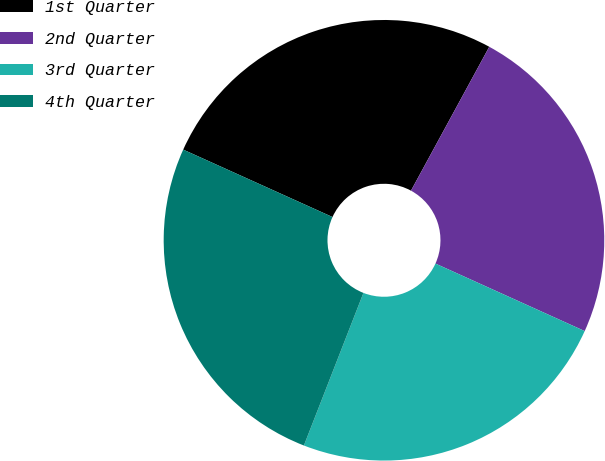Convert chart. <chart><loc_0><loc_0><loc_500><loc_500><pie_chart><fcel>1st Quarter<fcel>2nd Quarter<fcel>3rd Quarter<fcel>4th Quarter<nl><fcel>26.18%<fcel>23.83%<fcel>24.16%<fcel>25.83%<nl></chart> 